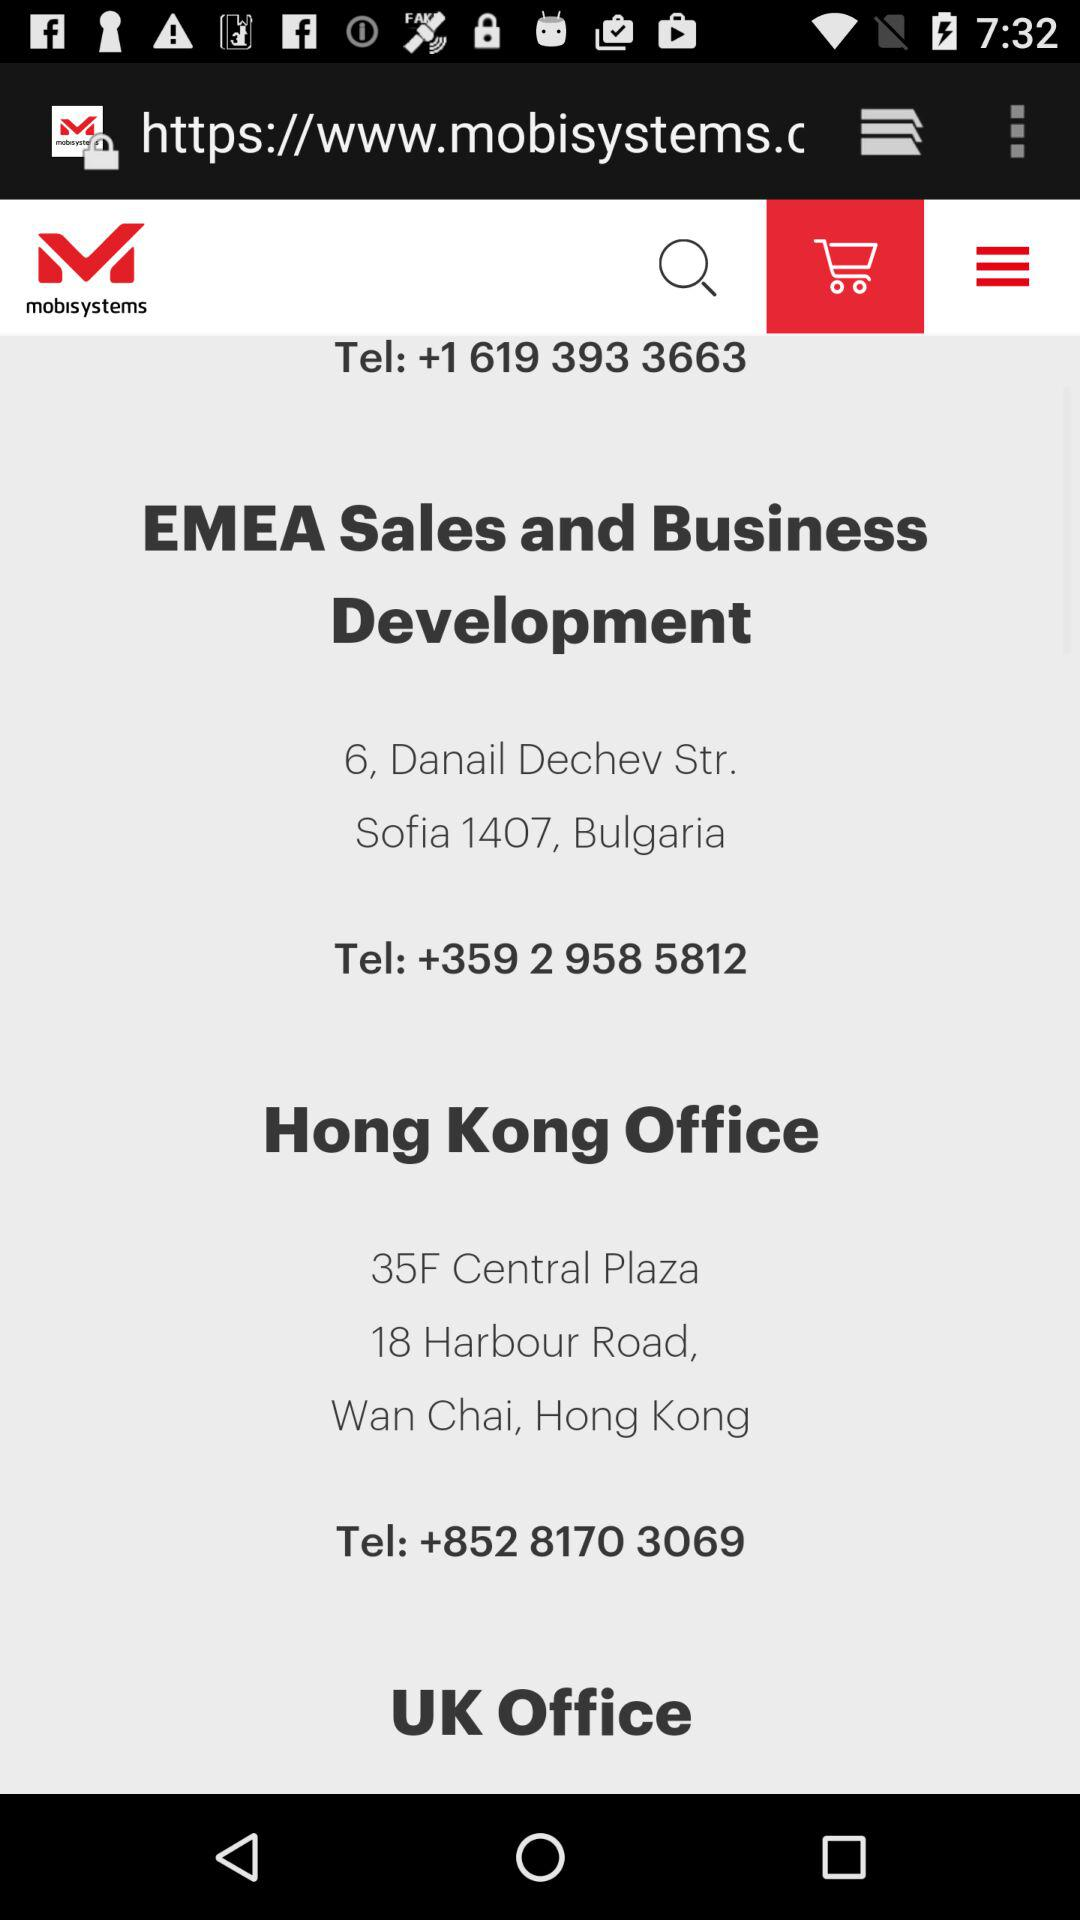What is the contact number for "EMEA Sales and Business Development"? The contact number is +359 2 958 5812. 